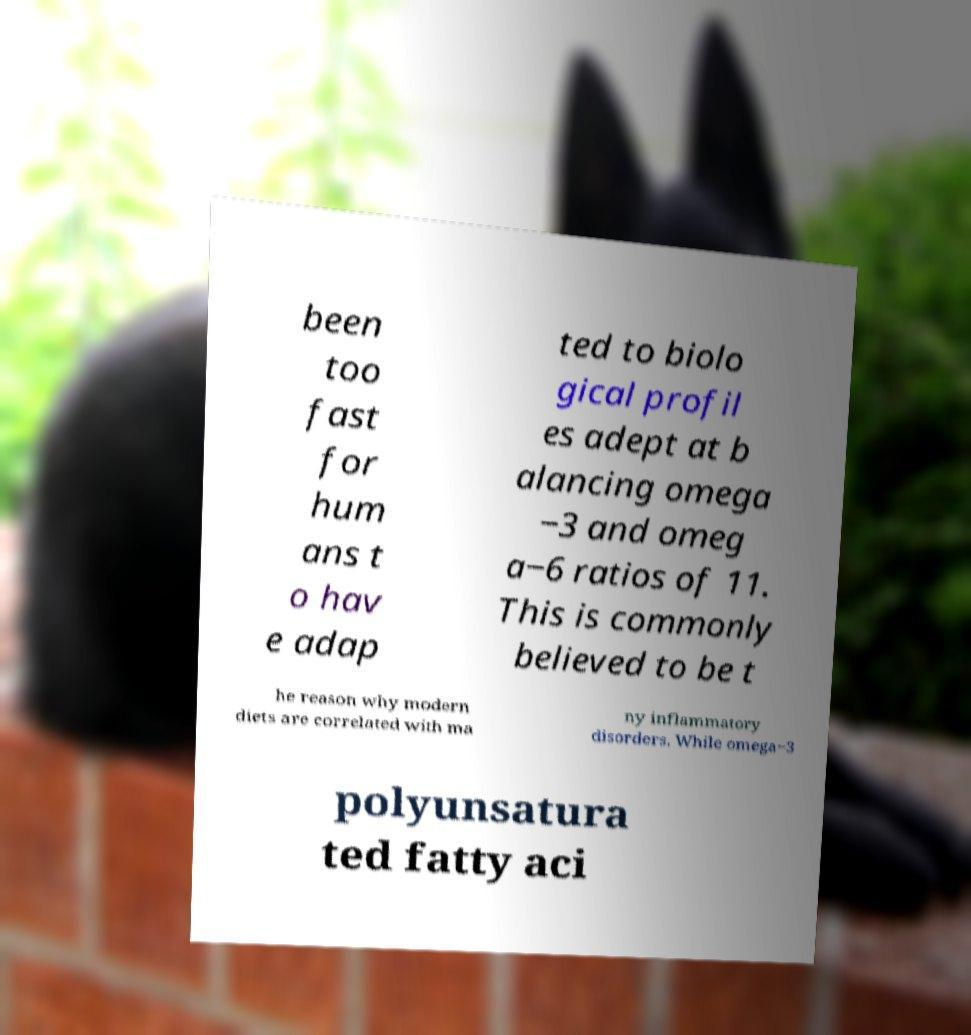Can you accurately transcribe the text from the provided image for me? been too fast for hum ans t o hav e adap ted to biolo gical profil es adept at b alancing omega −3 and omeg a−6 ratios of 11. This is commonly believed to be t he reason why modern diets are correlated with ma ny inflammatory disorders. While omega−3 polyunsatura ted fatty aci 